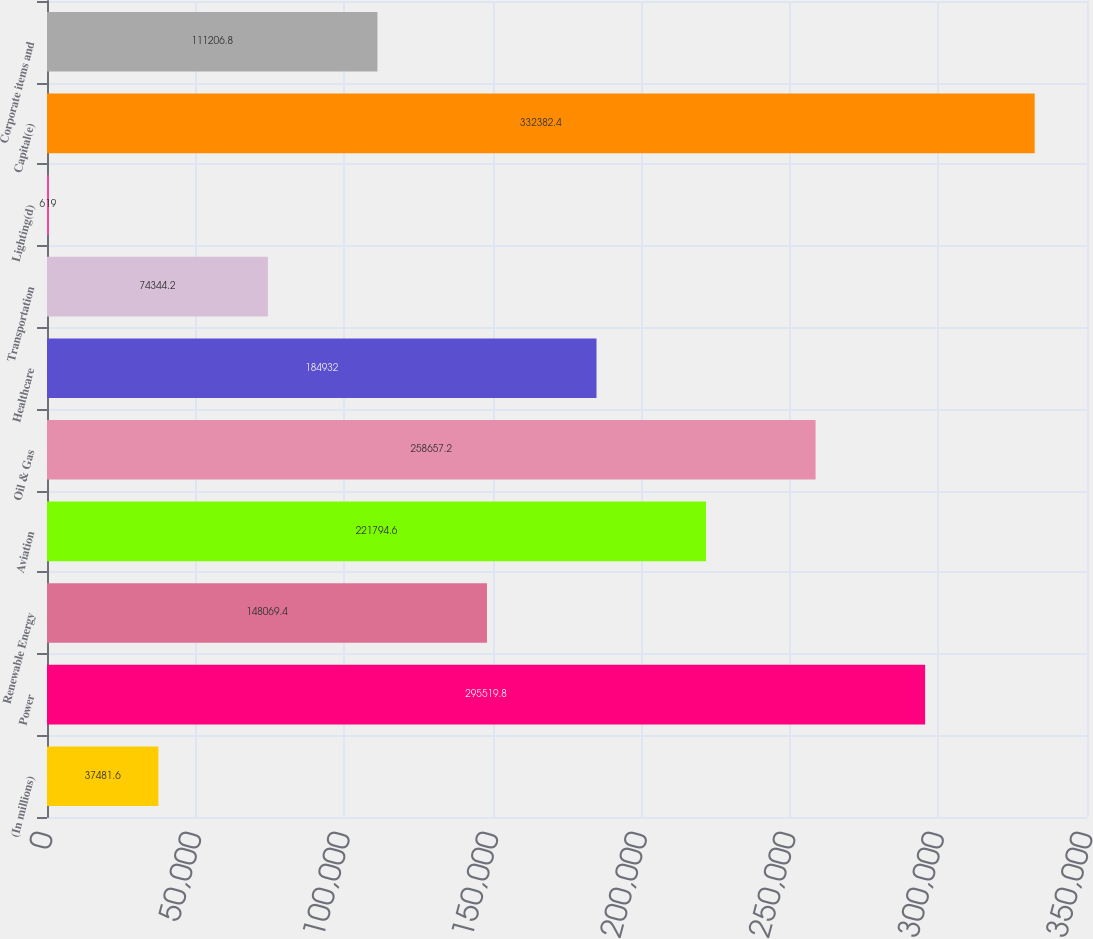Convert chart to OTSL. <chart><loc_0><loc_0><loc_500><loc_500><bar_chart><fcel>(In millions)<fcel>Power<fcel>Renewable Energy<fcel>Aviation<fcel>Oil & Gas<fcel>Healthcare<fcel>Transportation<fcel>Lighting(d)<fcel>Capital(e)<fcel>Corporate items and<nl><fcel>37481.6<fcel>295520<fcel>148069<fcel>221795<fcel>258657<fcel>184932<fcel>74344.2<fcel>619<fcel>332382<fcel>111207<nl></chart> 